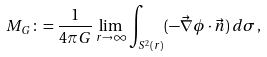<formula> <loc_0><loc_0><loc_500><loc_500>M _ { G } \colon = \frac { 1 } { 4 \pi G } \lim _ { r \rightarrow \infty } \int _ { S ^ { 2 } ( r ) } ( - \vec { \nabla } \phi \cdot \vec { n } ) \, d \sigma \, ,</formula> 